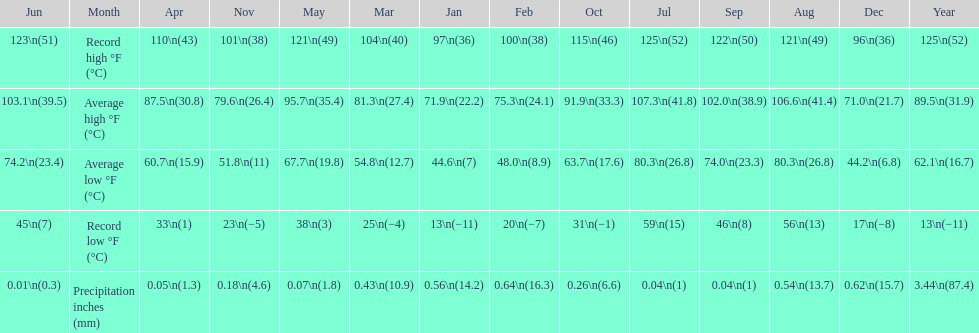How long was the monthly average temperature 100 degrees or more? 4 months. 